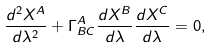<formula> <loc_0><loc_0><loc_500><loc_500>\frac { d ^ { 2 } X ^ { A } } { d \lambda ^ { 2 } } + \Gamma _ { B C } ^ { A } \frac { d X ^ { B } } { d \lambda } \frac { d X ^ { C } } { d \lambda } = 0 ,</formula> 